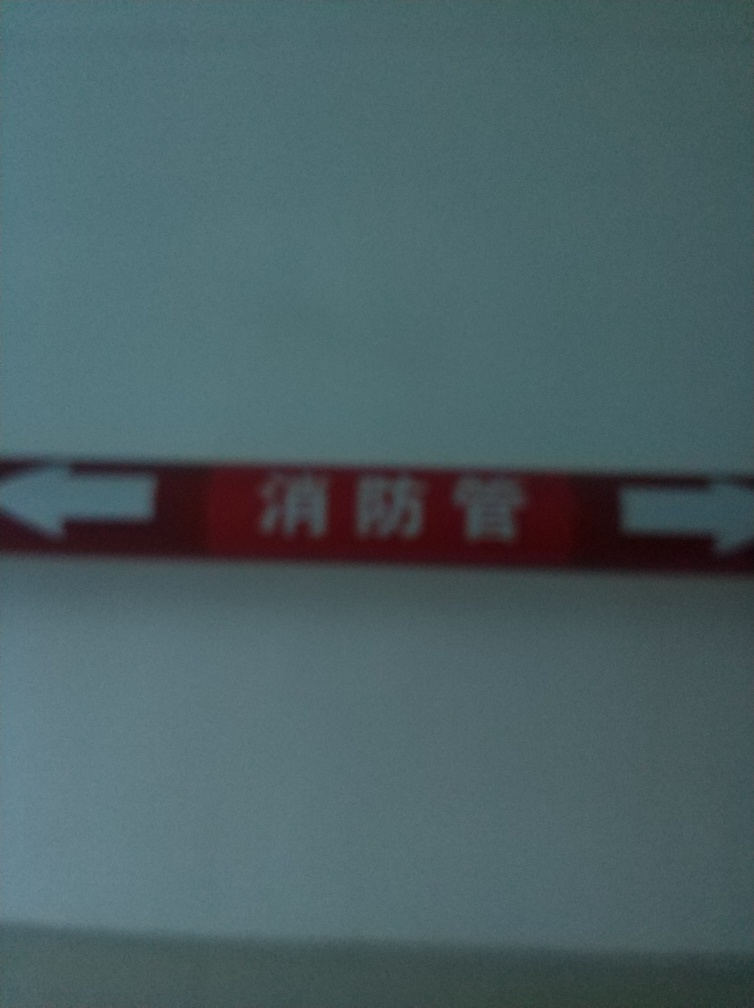What is the overall clarity of this image? The clarity of the image is quite low, hampering the ability to discern fine details. The focus is soft, which leads to a blurring of the texts or symbols present. Despite this, the brighter colors such as the red background are still noticeable. It appears to be a sign of some sort, potentially containing text or instructions. Improving the image's sharpness would greatly benefit the understanding of its content. 